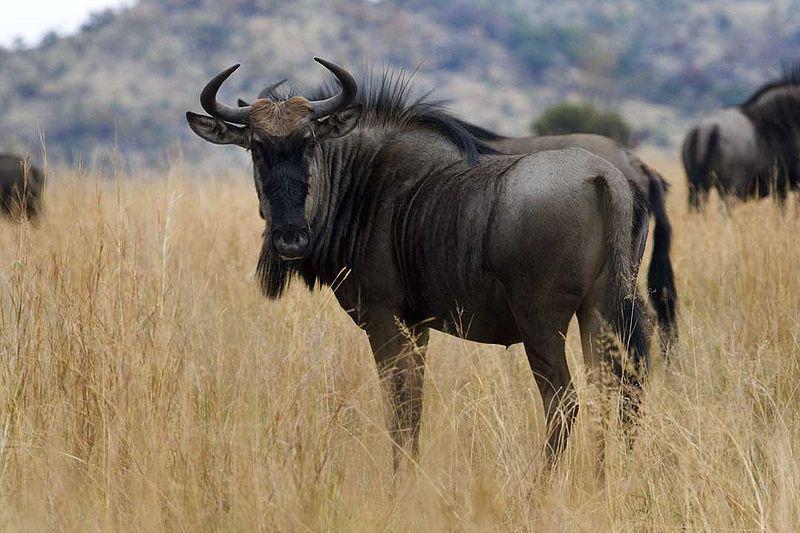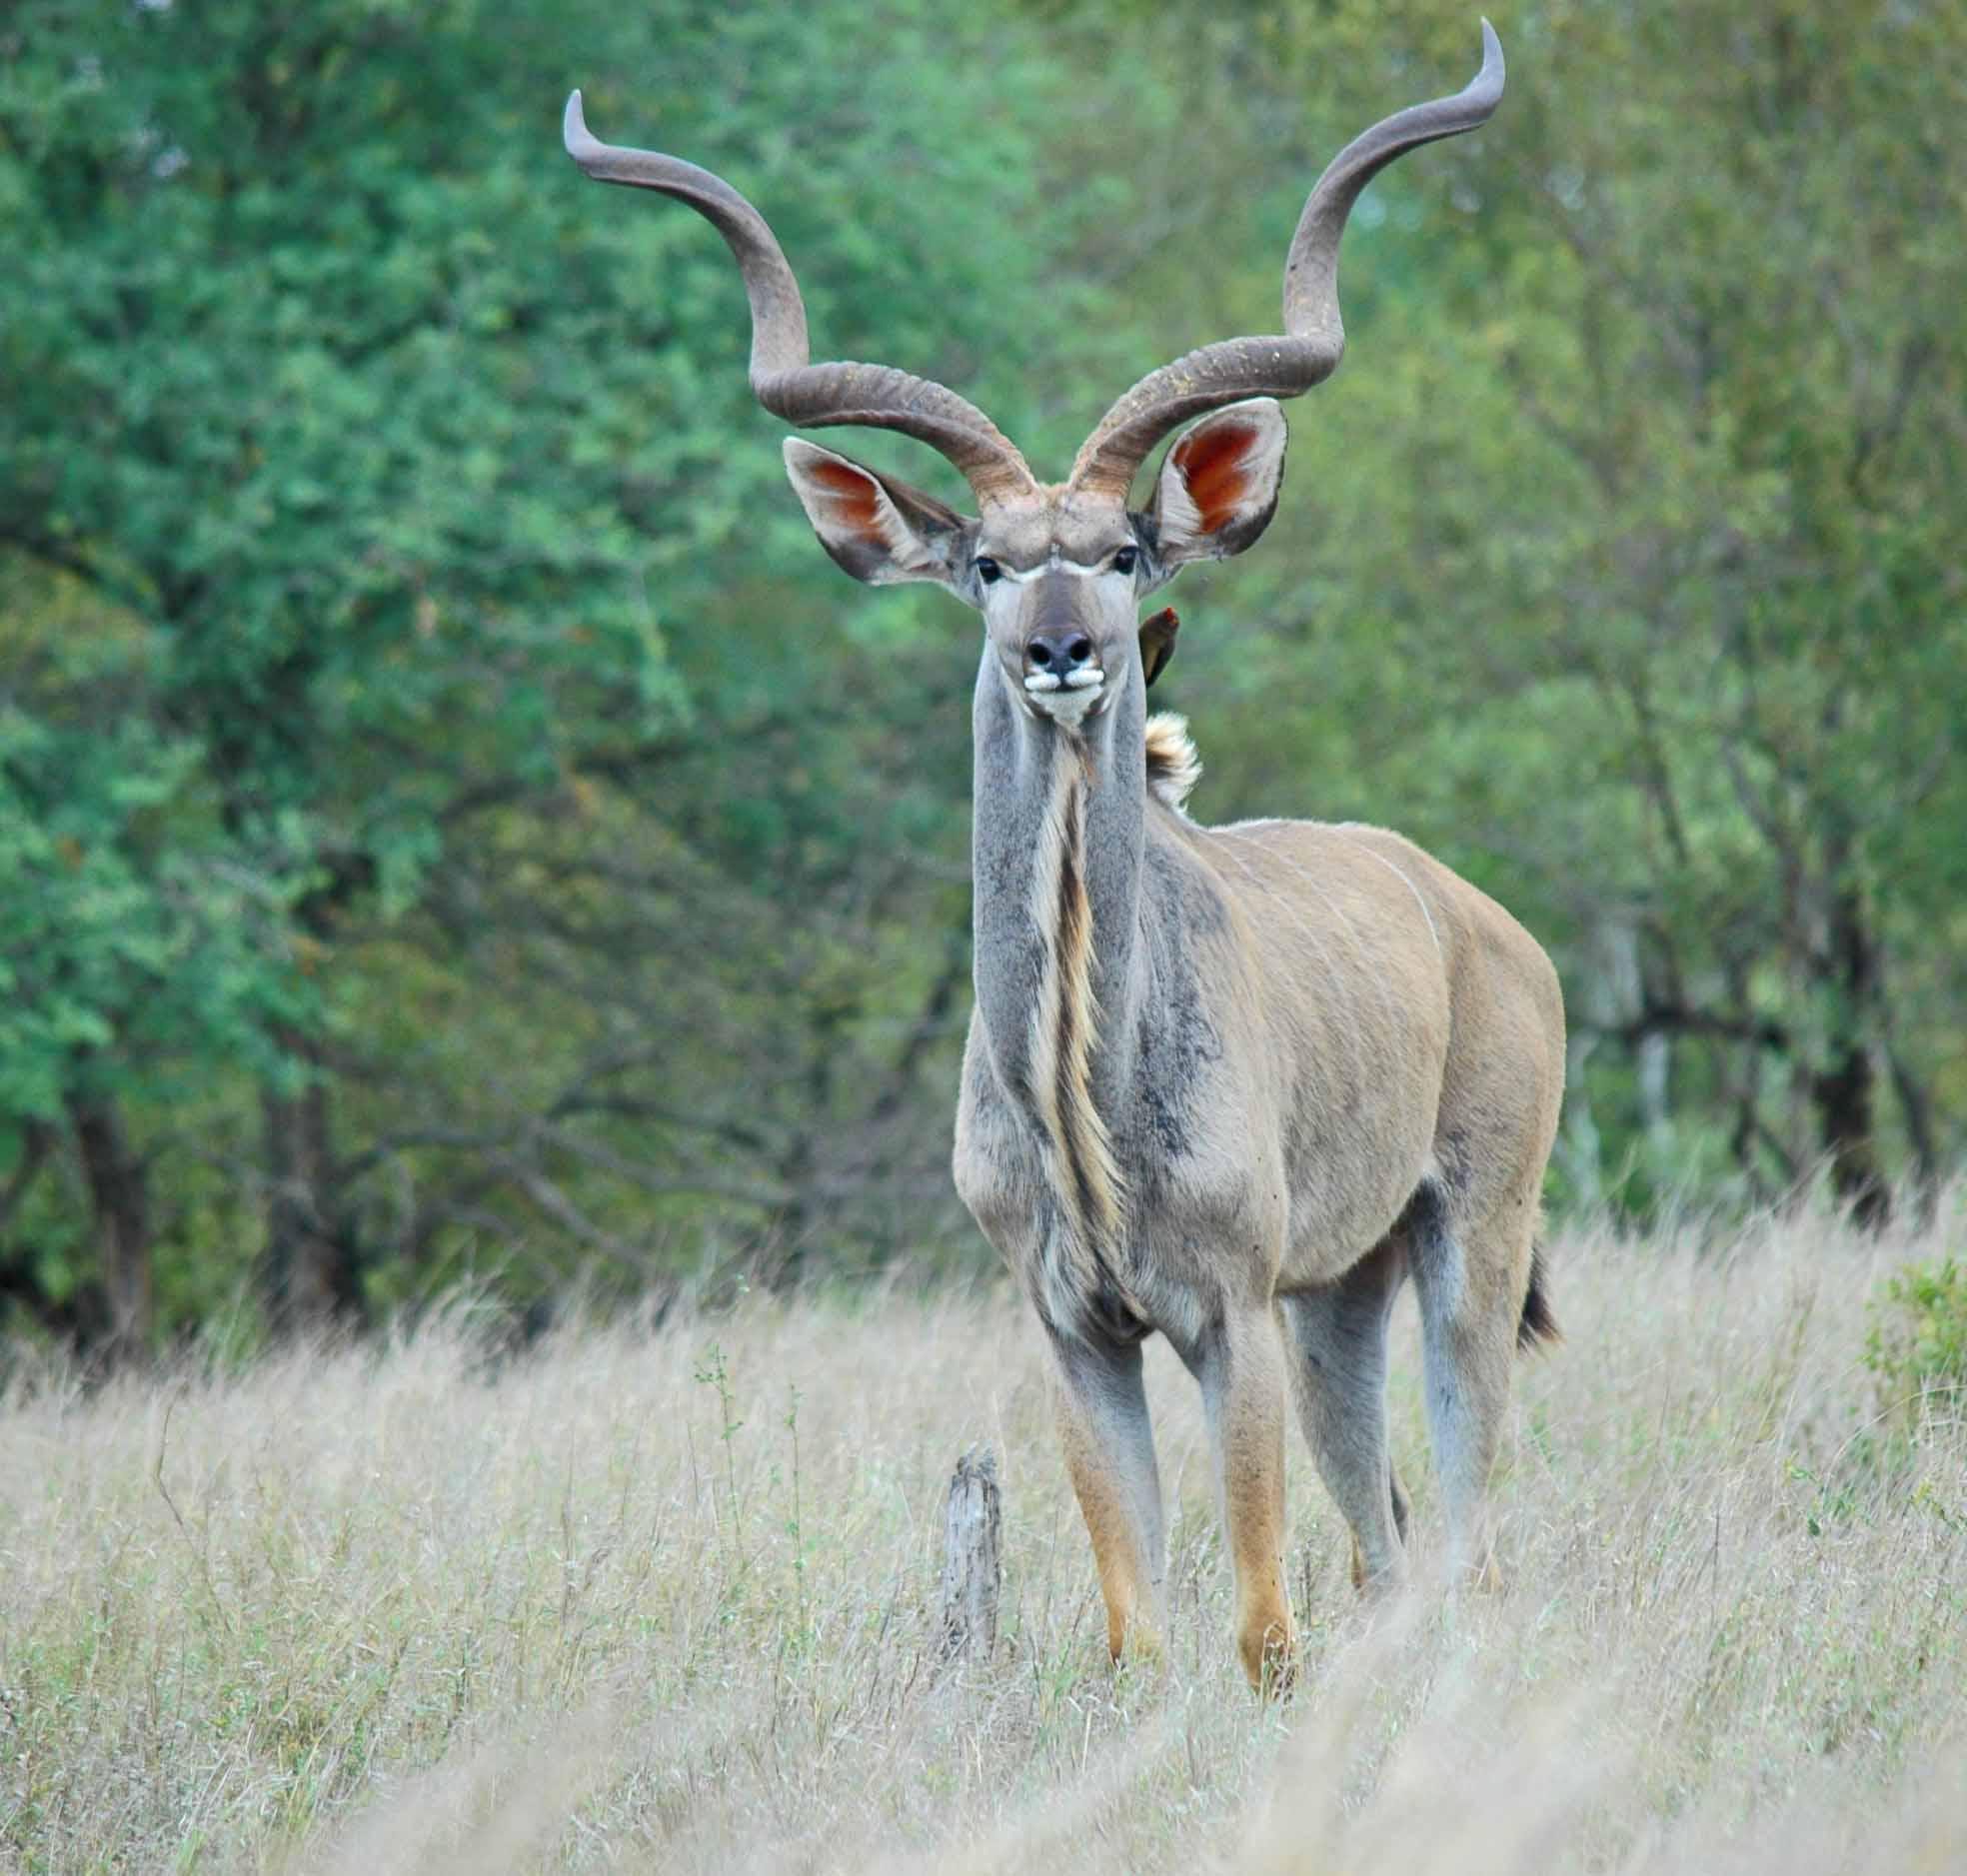The first image is the image on the left, the second image is the image on the right. Assess this claim about the two images: "Each image has one animal that has horns.". Correct or not? Answer yes or no. Yes. 